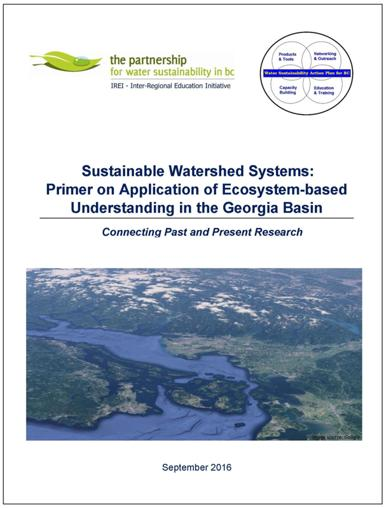Could you describe any specific methods or approaches that the publication might promote for sustainable watershed management? While specifics are not visible in the image, the publication probably advocates for methods like collaborative governance, which involves multiple stakeholders, the use of advanced hydrological models to predict and plan for water-related issues, and perhaps innovative green infrastructure solutions that mimic natural processes to manage runoff and preserve water quality. 